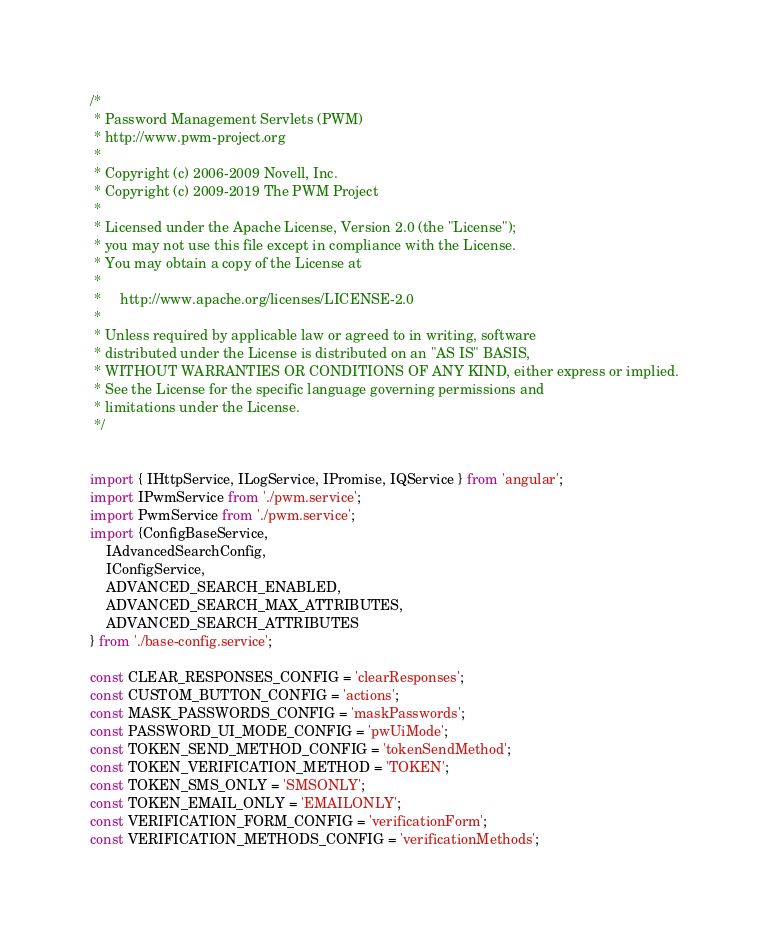Convert code to text. <code><loc_0><loc_0><loc_500><loc_500><_TypeScript_>/*
 * Password Management Servlets (PWM)
 * http://www.pwm-project.org
 *
 * Copyright (c) 2006-2009 Novell, Inc.
 * Copyright (c) 2009-2019 The PWM Project
 *
 * Licensed under the Apache License, Version 2.0 (the "License");
 * you may not use this file except in compliance with the License.
 * You may obtain a copy of the License at
 *
 *     http://www.apache.org/licenses/LICENSE-2.0
 *
 * Unless required by applicable law or agreed to in writing, software
 * distributed under the License is distributed on an "AS IS" BASIS,
 * WITHOUT WARRANTIES OR CONDITIONS OF ANY KIND, either express or implied.
 * See the License for the specific language governing permissions and
 * limitations under the License.
 */


import { IHttpService, ILogService, IPromise, IQService } from 'angular';
import IPwmService from './pwm.service';
import PwmService from './pwm.service';
import {ConfigBaseService,
    IAdvancedSearchConfig,
    IConfigService,
    ADVANCED_SEARCH_ENABLED,
    ADVANCED_SEARCH_MAX_ATTRIBUTES,
    ADVANCED_SEARCH_ATTRIBUTES
} from './base-config.service';

const CLEAR_RESPONSES_CONFIG = 'clearResponses';
const CUSTOM_BUTTON_CONFIG = 'actions';
const MASK_PASSWORDS_CONFIG = 'maskPasswords';
const PASSWORD_UI_MODE_CONFIG = 'pwUiMode';
const TOKEN_SEND_METHOD_CONFIG = 'tokenSendMethod';
const TOKEN_VERIFICATION_METHOD = 'TOKEN';
const TOKEN_SMS_ONLY = 'SMSONLY';
const TOKEN_EMAIL_ONLY = 'EMAILONLY';
const VERIFICATION_FORM_CONFIG = 'verificationForm';
const VERIFICATION_METHODS_CONFIG = 'verificationMethods';</code> 